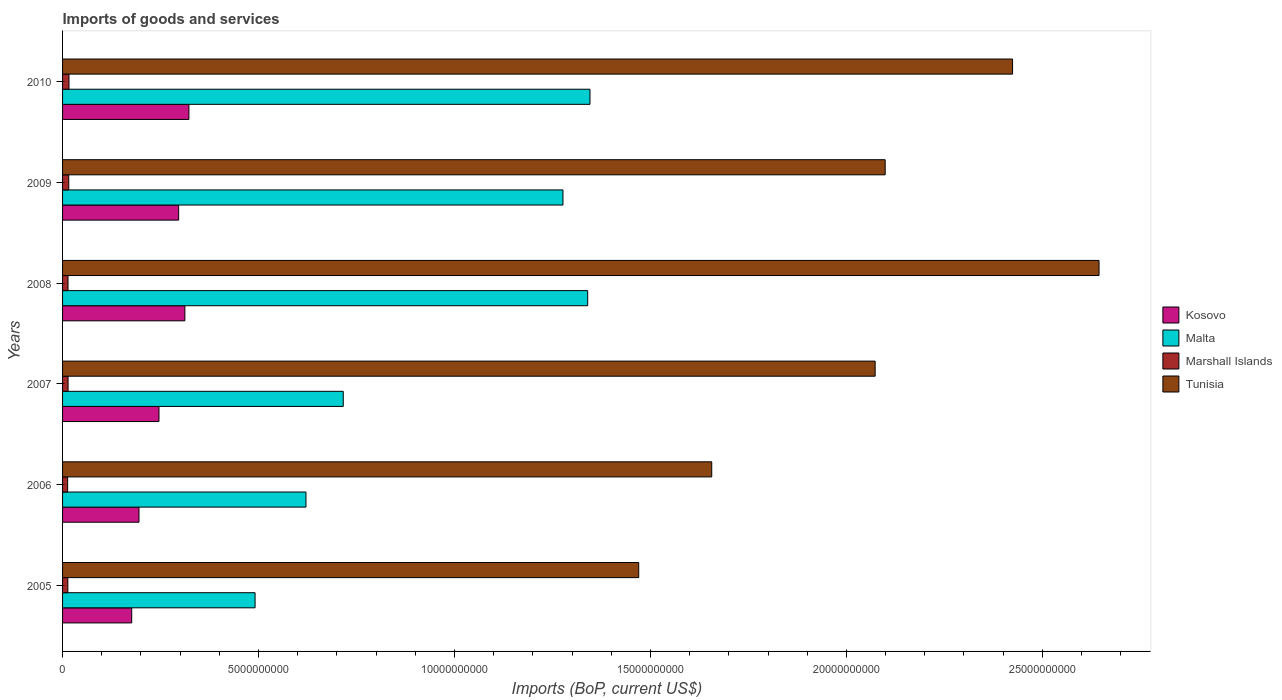How many different coloured bars are there?
Make the answer very short. 4. How many groups of bars are there?
Your answer should be compact. 6. Are the number of bars on each tick of the Y-axis equal?
Provide a succinct answer. Yes. In how many cases, is the number of bars for a given year not equal to the number of legend labels?
Ensure brevity in your answer.  0. What is the amount spent on imports in Kosovo in 2005?
Your answer should be compact. 1.76e+09. Across all years, what is the maximum amount spent on imports in Marshall Islands?
Your response must be concise. 1.64e+08. Across all years, what is the minimum amount spent on imports in Kosovo?
Keep it short and to the point. 1.76e+09. In which year was the amount spent on imports in Tunisia maximum?
Your answer should be very brief. 2008. What is the total amount spent on imports in Kosovo in the graph?
Give a very brief answer. 1.55e+1. What is the difference between the amount spent on imports in Marshall Islands in 2006 and that in 2009?
Offer a terse response. -2.88e+07. What is the difference between the amount spent on imports in Malta in 2006 and the amount spent on imports in Marshall Islands in 2009?
Provide a short and direct response. 6.05e+09. What is the average amount spent on imports in Kosovo per year?
Your answer should be compact. 2.58e+09. In the year 2007, what is the difference between the amount spent on imports in Malta and amount spent on imports in Tunisia?
Offer a terse response. -1.36e+1. What is the ratio of the amount spent on imports in Kosovo in 2007 to that in 2008?
Your answer should be compact. 0.79. Is the difference between the amount spent on imports in Malta in 2006 and 2009 greater than the difference between the amount spent on imports in Tunisia in 2006 and 2009?
Give a very brief answer. No. What is the difference between the highest and the second highest amount spent on imports in Marshall Islands?
Offer a very short reply. 5.73e+06. What is the difference between the highest and the lowest amount spent on imports in Tunisia?
Make the answer very short. 1.17e+1. In how many years, is the amount spent on imports in Tunisia greater than the average amount spent on imports in Tunisia taken over all years?
Offer a terse response. 4. Is the sum of the amount spent on imports in Tunisia in 2005 and 2009 greater than the maximum amount spent on imports in Malta across all years?
Provide a short and direct response. Yes. What does the 3rd bar from the top in 2008 represents?
Make the answer very short. Malta. What does the 3rd bar from the bottom in 2007 represents?
Offer a terse response. Marshall Islands. Is it the case that in every year, the sum of the amount spent on imports in Marshall Islands and amount spent on imports in Kosovo is greater than the amount spent on imports in Malta?
Provide a short and direct response. No. How many bars are there?
Ensure brevity in your answer.  24. How many years are there in the graph?
Offer a terse response. 6. What is the difference between two consecutive major ticks on the X-axis?
Your answer should be very brief. 5.00e+09. Are the values on the major ticks of X-axis written in scientific E-notation?
Your response must be concise. No. Does the graph contain grids?
Ensure brevity in your answer.  No. Where does the legend appear in the graph?
Give a very brief answer. Center right. How are the legend labels stacked?
Provide a short and direct response. Vertical. What is the title of the graph?
Ensure brevity in your answer.  Imports of goods and services. Does "St. Vincent and the Grenadines" appear as one of the legend labels in the graph?
Ensure brevity in your answer.  No. What is the label or title of the X-axis?
Your answer should be very brief. Imports (BoP, current US$). What is the label or title of the Y-axis?
Offer a terse response. Years. What is the Imports (BoP, current US$) of Kosovo in 2005?
Provide a short and direct response. 1.76e+09. What is the Imports (BoP, current US$) of Malta in 2005?
Give a very brief answer. 4.91e+09. What is the Imports (BoP, current US$) in Marshall Islands in 2005?
Your answer should be compact. 1.35e+08. What is the Imports (BoP, current US$) in Tunisia in 2005?
Your response must be concise. 1.47e+1. What is the Imports (BoP, current US$) of Kosovo in 2006?
Offer a terse response. 1.95e+09. What is the Imports (BoP, current US$) of Malta in 2006?
Give a very brief answer. 6.21e+09. What is the Imports (BoP, current US$) of Marshall Islands in 2006?
Your answer should be very brief. 1.29e+08. What is the Imports (BoP, current US$) in Tunisia in 2006?
Your response must be concise. 1.66e+1. What is the Imports (BoP, current US$) of Kosovo in 2007?
Your answer should be very brief. 2.46e+09. What is the Imports (BoP, current US$) of Malta in 2007?
Your answer should be compact. 7.16e+09. What is the Imports (BoP, current US$) in Marshall Islands in 2007?
Offer a very short reply. 1.41e+08. What is the Imports (BoP, current US$) in Tunisia in 2007?
Offer a terse response. 2.07e+1. What is the Imports (BoP, current US$) in Kosovo in 2008?
Keep it short and to the point. 3.12e+09. What is the Imports (BoP, current US$) in Malta in 2008?
Provide a succinct answer. 1.34e+1. What is the Imports (BoP, current US$) in Marshall Islands in 2008?
Ensure brevity in your answer.  1.39e+08. What is the Imports (BoP, current US$) in Tunisia in 2008?
Offer a terse response. 2.64e+1. What is the Imports (BoP, current US$) in Kosovo in 2009?
Your response must be concise. 2.96e+09. What is the Imports (BoP, current US$) in Malta in 2009?
Provide a short and direct response. 1.28e+1. What is the Imports (BoP, current US$) in Marshall Islands in 2009?
Ensure brevity in your answer.  1.58e+08. What is the Imports (BoP, current US$) in Tunisia in 2009?
Ensure brevity in your answer.  2.10e+1. What is the Imports (BoP, current US$) in Kosovo in 2010?
Make the answer very short. 3.22e+09. What is the Imports (BoP, current US$) in Malta in 2010?
Provide a succinct answer. 1.35e+1. What is the Imports (BoP, current US$) of Marshall Islands in 2010?
Your answer should be very brief. 1.64e+08. What is the Imports (BoP, current US$) of Tunisia in 2010?
Ensure brevity in your answer.  2.42e+1. Across all years, what is the maximum Imports (BoP, current US$) in Kosovo?
Provide a short and direct response. 3.22e+09. Across all years, what is the maximum Imports (BoP, current US$) in Malta?
Your answer should be very brief. 1.35e+1. Across all years, what is the maximum Imports (BoP, current US$) of Marshall Islands?
Keep it short and to the point. 1.64e+08. Across all years, what is the maximum Imports (BoP, current US$) of Tunisia?
Provide a short and direct response. 2.64e+1. Across all years, what is the minimum Imports (BoP, current US$) in Kosovo?
Your answer should be compact. 1.76e+09. Across all years, what is the minimum Imports (BoP, current US$) in Malta?
Keep it short and to the point. 4.91e+09. Across all years, what is the minimum Imports (BoP, current US$) of Marshall Islands?
Give a very brief answer. 1.29e+08. Across all years, what is the minimum Imports (BoP, current US$) of Tunisia?
Your response must be concise. 1.47e+1. What is the total Imports (BoP, current US$) of Kosovo in the graph?
Keep it short and to the point. 1.55e+1. What is the total Imports (BoP, current US$) in Malta in the graph?
Give a very brief answer. 5.79e+1. What is the total Imports (BoP, current US$) in Marshall Islands in the graph?
Give a very brief answer. 8.65e+08. What is the total Imports (BoP, current US$) in Tunisia in the graph?
Keep it short and to the point. 1.24e+11. What is the difference between the Imports (BoP, current US$) in Kosovo in 2005 and that in 2006?
Your response must be concise. -1.86e+08. What is the difference between the Imports (BoP, current US$) in Malta in 2005 and that in 2006?
Offer a terse response. -1.30e+09. What is the difference between the Imports (BoP, current US$) of Marshall Islands in 2005 and that in 2006?
Keep it short and to the point. 5.65e+06. What is the difference between the Imports (BoP, current US$) in Tunisia in 2005 and that in 2006?
Keep it short and to the point. -1.86e+09. What is the difference between the Imports (BoP, current US$) of Kosovo in 2005 and that in 2007?
Offer a very short reply. -6.96e+08. What is the difference between the Imports (BoP, current US$) of Malta in 2005 and that in 2007?
Keep it short and to the point. -2.25e+09. What is the difference between the Imports (BoP, current US$) of Marshall Islands in 2005 and that in 2007?
Give a very brief answer. -5.87e+06. What is the difference between the Imports (BoP, current US$) in Tunisia in 2005 and that in 2007?
Give a very brief answer. -6.03e+09. What is the difference between the Imports (BoP, current US$) in Kosovo in 2005 and that in 2008?
Your response must be concise. -1.36e+09. What is the difference between the Imports (BoP, current US$) in Malta in 2005 and that in 2008?
Your answer should be compact. -8.49e+09. What is the difference between the Imports (BoP, current US$) of Marshall Islands in 2005 and that in 2008?
Provide a succinct answer. -4.35e+06. What is the difference between the Imports (BoP, current US$) of Tunisia in 2005 and that in 2008?
Your answer should be compact. -1.17e+1. What is the difference between the Imports (BoP, current US$) in Kosovo in 2005 and that in 2009?
Keep it short and to the point. -1.20e+09. What is the difference between the Imports (BoP, current US$) in Malta in 2005 and that in 2009?
Offer a very short reply. -7.86e+09. What is the difference between the Imports (BoP, current US$) of Marshall Islands in 2005 and that in 2009?
Ensure brevity in your answer.  -2.31e+07. What is the difference between the Imports (BoP, current US$) in Tunisia in 2005 and that in 2009?
Your answer should be compact. -6.29e+09. What is the difference between the Imports (BoP, current US$) in Kosovo in 2005 and that in 2010?
Ensure brevity in your answer.  -1.46e+09. What is the difference between the Imports (BoP, current US$) in Malta in 2005 and that in 2010?
Give a very brief answer. -8.55e+09. What is the difference between the Imports (BoP, current US$) of Marshall Islands in 2005 and that in 2010?
Provide a succinct answer. -2.88e+07. What is the difference between the Imports (BoP, current US$) in Tunisia in 2005 and that in 2010?
Provide a succinct answer. -9.54e+09. What is the difference between the Imports (BoP, current US$) in Kosovo in 2006 and that in 2007?
Provide a short and direct response. -5.10e+08. What is the difference between the Imports (BoP, current US$) in Malta in 2006 and that in 2007?
Offer a terse response. -9.52e+08. What is the difference between the Imports (BoP, current US$) of Marshall Islands in 2006 and that in 2007?
Your answer should be very brief. -1.15e+07. What is the difference between the Imports (BoP, current US$) in Tunisia in 2006 and that in 2007?
Ensure brevity in your answer.  -4.17e+09. What is the difference between the Imports (BoP, current US$) in Kosovo in 2006 and that in 2008?
Your answer should be very brief. -1.17e+09. What is the difference between the Imports (BoP, current US$) in Malta in 2006 and that in 2008?
Your response must be concise. -7.19e+09. What is the difference between the Imports (BoP, current US$) in Marshall Islands in 2006 and that in 2008?
Your answer should be compact. -9.99e+06. What is the difference between the Imports (BoP, current US$) of Tunisia in 2006 and that in 2008?
Provide a short and direct response. -9.88e+09. What is the difference between the Imports (BoP, current US$) of Kosovo in 2006 and that in 2009?
Ensure brevity in your answer.  -1.01e+09. What is the difference between the Imports (BoP, current US$) in Malta in 2006 and that in 2009?
Provide a short and direct response. -6.56e+09. What is the difference between the Imports (BoP, current US$) in Marshall Islands in 2006 and that in 2009?
Give a very brief answer. -2.88e+07. What is the difference between the Imports (BoP, current US$) of Tunisia in 2006 and that in 2009?
Offer a terse response. -4.43e+09. What is the difference between the Imports (BoP, current US$) of Kosovo in 2006 and that in 2010?
Offer a terse response. -1.27e+09. What is the difference between the Imports (BoP, current US$) in Malta in 2006 and that in 2010?
Your answer should be very brief. -7.25e+09. What is the difference between the Imports (BoP, current US$) in Marshall Islands in 2006 and that in 2010?
Provide a succinct answer. -3.45e+07. What is the difference between the Imports (BoP, current US$) of Tunisia in 2006 and that in 2010?
Your answer should be very brief. -7.68e+09. What is the difference between the Imports (BoP, current US$) of Kosovo in 2007 and that in 2008?
Offer a very short reply. -6.61e+08. What is the difference between the Imports (BoP, current US$) of Malta in 2007 and that in 2008?
Provide a succinct answer. -6.24e+09. What is the difference between the Imports (BoP, current US$) in Marshall Islands in 2007 and that in 2008?
Provide a succinct answer. 1.53e+06. What is the difference between the Imports (BoP, current US$) in Tunisia in 2007 and that in 2008?
Your answer should be compact. -5.71e+09. What is the difference between the Imports (BoP, current US$) in Kosovo in 2007 and that in 2009?
Your response must be concise. -5.01e+08. What is the difference between the Imports (BoP, current US$) in Malta in 2007 and that in 2009?
Your answer should be very brief. -5.61e+09. What is the difference between the Imports (BoP, current US$) of Marshall Islands in 2007 and that in 2009?
Your response must be concise. -1.72e+07. What is the difference between the Imports (BoP, current US$) in Tunisia in 2007 and that in 2009?
Give a very brief answer. -2.56e+08. What is the difference between the Imports (BoP, current US$) in Kosovo in 2007 and that in 2010?
Your response must be concise. -7.63e+08. What is the difference between the Imports (BoP, current US$) of Malta in 2007 and that in 2010?
Your response must be concise. -6.30e+09. What is the difference between the Imports (BoP, current US$) in Marshall Islands in 2007 and that in 2010?
Make the answer very short. -2.30e+07. What is the difference between the Imports (BoP, current US$) of Tunisia in 2007 and that in 2010?
Your answer should be very brief. -3.51e+09. What is the difference between the Imports (BoP, current US$) of Kosovo in 2008 and that in 2009?
Your response must be concise. 1.59e+08. What is the difference between the Imports (BoP, current US$) in Malta in 2008 and that in 2009?
Provide a short and direct response. 6.31e+08. What is the difference between the Imports (BoP, current US$) in Marshall Islands in 2008 and that in 2009?
Your answer should be very brief. -1.88e+07. What is the difference between the Imports (BoP, current US$) of Tunisia in 2008 and that in 2009?
Your answer should be compact. 5.46e+09. What is the difference between the Imports (BoP, current US$) of Kosovo in 2008 and that in 2010?
Your answer should be compact. -1.03e+08. What is the difference between the Imports (BoP, current US$) of Malta in 2008 and that in 2010?
Give a very brief answer. -5.88e+07. What is the difference between the Imports (BoP, current US$) of Marshall Islands in 2008 and that in 2010?
Provide a succinct answer. -2.45e+07. What is the difference between the Imports (BoP, current US$) in Tunisia in 2008 and that in 2010?
Your answer should be very brief. 2.21e+09. What is the difference between the Imports (BoP, current US$) of Kosovo in 2009 and that in 2010?
Ensure brevity in your answer.  -2.62e+08. What is the difference between the Imports (BoP, current US$) of Malta in 2009 and that in 2010?
Your answer should be very brief. -6.89e+08. What is the difference between the Imports (BoP, current US$) in Marshall Islands in 2009 and that in 2010?
Ensure brevity in your answer.  -5.73e+06. What is the difference between the Imports (BoP, current US$) of Tunisia in 2009 and that in 2010?
Give a very brief answer. -3.25e+09. What is the difference between the Imports (BoP, current US$) of Kosovo in 2005 and the Imports (BoP, current US$) of Malta in 2006?
Make the answer very short. -4.45e+09. What is the difference between the Imports (BoP, current US$) in Kosovo in 2005 and the Imports (BoP, current US$) in Marshall Islands in 2006?
Offer a terse response. 1.64e+09. What is the difference between the Imports (BoP, current US$) of Kosovo in 2005 and the Imports (BoP, current US$) of Tunisia in 2006?
Ensure brevity in your answer.  -1.48e+1. What is the difference between the Imports (BoP, current US$) in Malta in 2005 and the Imports (BoP, current US$) in Marshall Islands in 2006?
Offer a terse response. 4.78e+09. What is the difference between the Imports (BoP, current US$) in Malta in 2005 and the Imports (BoP, current US$) in Tunisia in 2006?
Your answer should be compact. -1.17e+1. What is the difference between the Imports (BoP, current US$) in Marshall Islands in 2005 and the Imports (BoP, current US$) in Tunisia in 2006?
Your response must be concise. -1.64e+1. What is the difference between the Imports (BoP, current US$) of Kosovo in 2005 and the Imports (BoP, current US$) of Malta in 2007?
Give a very brief answer. -5.40e+09. What is the difference between the Imports (BoP, current US$) in Kosovo in 2005 and the Imports (BoP, current US$) in Marshall Islands in 2007?
Provide a succinct answer. 1.62e+09. What is the difference between the Imports (BoP, current US$) of Kosovo in 2005 and the Imports (BoP, current US$) of Tunisia in 2007?
Your answer should be compact. -1.90e+1. What is the difference between the Imports (BoP, current US$) in Malta in 2005 and the Imports (BoP, current US$) in Marshall Islands in 2007?
Ensure brevity in your answer.  4.77e+09. What is the difference between the Imports (BoP, current US$) in Malta in 2005 and the Imports (BoP, current US$) in Tunisia in 2007?
Your answer should be compact. -1.58e+1. What is the difference between the Imports (BoP, current US$) of Marshall Islands in 2005 and the Imports (BoP, current US$) of Tunisia in 2007?
Offer a terse response. -2.06e+1. What is the difference between the Imports (BoP, current US$) in Kosovo in 2005 and the Imports (BoP, current US$) in Malta in 2008?
Offer a terse response. -1.16e+1. What is the difference between the Imports (BoP, current US$) in Kosovo in 2005 and the Imports (BoP, current US$) in Marshall Islands in 2008?
Keep it short and to the point. 1.63e+09. What is the difference between the Imports (BoP, current US$) in Kosovo in 2005 and the Imports (BoP, current US$) in Tunisia in 2008?
Provide a succinct answer. -2.47e+1. What is the difference between the Imports (BoP, current US$) in Malta in 2005 and the Imports (BoP, current US$) in Marshall Islands in 2008?
Keep it short and to the point. 4.77e+09. What is the difference between the Imports (BoP, current US$) of Malta in 2005 and the Imports (BoP, current US$) of Tunisia in 2008?
Your answer should be compact. -2.15e+1. What is the difference between the Imports (BoP, current US$) in Marshall Islands in 2005 and the Imports (BoP, current US$) in Tunisia in 2008?
Ensure brevity in your answer.  -2.63e+1. What is the difference between the Imports (BoP, current US$) in Kosovo in 2005 and the Imports (BoP, current US$) in Malta in 2009?
Offer a very short reply. -1.10e+1. What is the difference between the Imports (BoP, current US$) of Kosovo in 2005 and the Imports (BoP, current US$) of Marshall Islands in 2009?
Make the answer very short. 1.61e+09. What is the difference between the Imports (BoP, current US$) in Kosovo in 2005 and the Imports (BoP, current US$) in Tunisia in 2009?
Make the answer very short. -1.92e+1. What is the difference between the Imports (BoP, current US$) of Malta in 2005 and the Imports (BoP, current US$) of Marshall Islands in 2009?
Your answer should be compact. 4.75e+09. What is the difference between the Imports (BoP, current US$) of Malta in 2005 and the Imports (BoP, current US$) of Tunisia in 2009?
Give a very brief answer. -1.61e+1. What is the difference between the Imports (BoP, current US$) in Marshall Islands in 2005 and the Imports (BoP, current US$) in Tunisia in 2009?
Ensure brevity in your answer.  -2.09e+1. What is the difference between the Imports (BoP, current US$) in Kosovo in 2005 and the Imports (BoP, current US$) in Malta in 2010?
Ensure brevity in your answer.  -1.17e+1. What is the difference between the Imports (BoP, current US$) of Kosovo in 2005 and the Imports (BoP, current US$) of Marshall Islands in 2010?
Make the answer very short. 1.60e+09. What is the difference between the Imports (BoP, current US$) in Kosovo in 2005 and the Imports (BoP, current US$) in Tunisia in 2010?
Make the answer very short. -2.25e+1. What is the difference between the Imports (BoP, current US$) of Malta in 2005 and the Imports (BoP, current US$) of Marshall Islands in 2010?
Provide a succinct answer. 4.75e+09. What is the difference between the Imports (BoP, current US$) of Malta in 2005 and the Imports (BoP, current US$) of Tunisia in 2010?
Your response must be concise. -1.93e+1. What is the difference between the Imports (BoP, current US$) in Marshall Islands in 2005 and the Imports (BoP, current US$) in Tunisia in 2010?
Provide a short and direct response. -2.41e+1. What is the difference between the Imports (BoP, current US$) of Kosovo in 2006 and the Imports (BoP, current US$) of Malta in 2007?
Keep it short and to the point. -5.21e+09. What is the difference between the Imports (BoP, current US$) in Kosovo in 2006 and the Imports (BoP, current US$) in Marshall Islands in 2007?
Your response must be concise. 1.81e+09. What is the difference between the Imports (BoP, current US$) of Kosovo in 2006 and the Imports (BoP, current US$) of Tunisia in 2007?
Provide a short and direct response. -1.88e+1. What is the difference between the Imports (BoP, current US$) in Malta in 2006 and the Imports (BoP, current US$) in Marshall Islands in 2007?
Your answer should be compact. 6.07e+09. What is the difference between the Imports (BoP, current US$) in Malta in 2006 and the Imports (BoP, current US$) in Tunisia in 2007?
Offer a terse response. -1.45e+1. What is the difference between the Imports (BoP, current US$) in Marshall Islands in 2006 and the Imports (BoP, current US$) in Tunisia in 2007?
Offer a terse response. -2.06e+1. What is the difference between the Imports (BoP, current US$) of Kosovo in 2006 and the Imports (BoP, current US$) of Malta in 2008?
Give a very brief answer. -1.14e+1. What is the difference between the Imports (BoP, current US$) of Kosovo in 2006 and the Imports (BoP, current US$) of Marshall Islands in 2008?
Provide a succinct answer. 1.81e+09. What is the difference between the Imports (BoP, current US$) of Kosovo in 2006 and the Imports (BoP, current US$) of Tunisia in 2008?
Give a very brief answer. -2.45e+1. What is the difference between the Imports (BoP, current US$) in Malta in 2006 and the Imports (BoP, current US$) in Marshall Islands in 2008?
Provide a succinct answer. 6.07e+09. What is the difference between the Imports (BoP, current US$) of Malta in 2006 and the Imports (BoP, current US$) of Tunisia in 2008?
Give a very brief answer. -2.02e+1. What is the difference between the Imports (BoP, current US$) of Marshall Islands in 2006 and the Imports (BoP, current US$) of Tunisia in 2008?
Your answer should be very brief. -2.63e+1. What is the difference between the Imports (BoP, current US$) of Kosovo in 2006 and the Imports (BoP, current US$) of Malta in 2009?
Make the answer very short. -1.08e+1. What is the difference between the Imports (BoP, current US$) in Kosovo in 2006 and the Imports (BoP, current US$) in Marshall Islands in 2009?
Offer a very short reply. 1.79e+09. What is the difference between the Imports (BoP, current US$) in Kosovo in 2006 and the Imports (BoP, current US$) in Tunisia in 2009?
Provide a short and direct response. -1.90e+1. What is the difference between the Imports (BoP, current US$) of Malta in 2006 and the Imports (BoP, current US$) of Marshall Islands in 2009?
Keep it short and to the point. 6.05e+09. What is the difference between the Imports (BoP, current US$) of Malta in 2006 and the Imports (BoP, current US$) of Tunisia in 2009?
Make the answer very short. -1.48e+1. What is the difference between the Imports (BoP, current US$) of Marshall Islands in 2006 and the Imports (BoP, current US$) of Tunisia in 2009?
Ensure brevity in your answer.  -2.09e+1. What is the difference between the Imports (BoP, current US$) in Kosovo in 2006 and the Imports (BoP, current US$) in Malta in 2010?
Provide a short and direct response. -1.15e+1. What is the difference between the Imports (BoP, current US$) in Kosovo in 2006 and the Imports (BoP, current US$) in Marshall Islands in 2010?
Offer a terse response. 1.79e+09. What is the difference between the Imports (BoP, current US$) of Kosovo in 2006 and the Imports (BoP, current US$) of Tunisia in 2010?
Your answer should be compact. -2.23e+1. What is the difference between the Imports (BoP, current US$) in Malta in 2006 and the Imports (BoP, current US$) in Marshall Islands in 2010?
Make the answer very short. 6.05e+09. What is the difference between the Imports (BoP, current US$) in Malta in 2006 and the Imports (BoP, current US$) in Tunisia in 2010?
Give a very brief answer. -1.80e+1. What is the difference between the Imports (BoP, current US$) in Marshall Islands in 2006 and the Imports (BoP, current US$) in Tunisia in 2010?
Offer a terse response. -2.41e+1. What is the difference between the Imports (BoP, current US$) in Kosovo in 2007 and the Imports (BoP, current US$) in Malta in 2008?
Give a very brief answer. -1.09e+1. What is the difference between the Imports (BoP, current US$) in Kosovo in 2007 and the Imports (BoP, current US$) in Marshall Islands in 2008?
Give a very brief answer. 2.32e+09. What is the difference between the Imports (BoP, current US$) in Kosovo in 2007 and the Imports (BoP, current US$) in Tunisia in 2008?
Your answer should be compact. -2.40e+1. What is the difference between the Imports (BoP, current US$) in Malta in 2007 and the Imports (BoP, current US$) in Marshall Islands in 2008?
Your response must be concise. 7.02e+09. What is the difference between the Imports (BoP, current US$) of Malta in 2007 and the Imports (BoP, current US$) of Tunisia in 2008?
Offer a terse response. -1.93e+1. What is the difference between the Imports (BoP, current US$) of Marshall Islands in 2007 and the Imports (BoP, current US$) of Tunisia in 2008?
Offer a very short reply. -2.63e+1. What is the difference between the Imports (BoP, current US$) in Kosovo in 2007 and the Imports (BoP, current US$) in Malta in 2009?
Offer a terse response. -1.03e+1. What is the difference between the Imports (BoP, current US$) in Kosovo in 2007 and the Imports (BoP, current US$) in Marshall Islands in 2009?
Offer a terse response. 2.30e+09. What is the difference between the Imports (BoP, current US$) in Kosovo in 2007 and the Imports (BoP, current US$) in Tunisia in 2009?
Offer a very short reply. -1.85e+1. What is the difference between the Imports (BoP, current US$) of Malta in 2007 and the Imports (BoP, current US$) of Marshall Islands in 2009?
Offer a very short reply. 7.00e+09. What is the difference between the Imports (BoP, current US$) in Malta in 2007 and the Imports (BoP, current US$) in Tunisia in 2009?
Provide a short and direct response. -1.38e+1. What is the difference between the Imports (BoP, current US$) in Marshall Islands in 2007 and the Imports (BoP, current US$) in Tunisia in 2009?
Provide a short and direct response. -2.08e+1. What is the difference between the Imports (BoP, current US$) of Kosovo in 2007 and the Imports (BoP, current US$) of Malta in 2010?
Provide a succinct answer. -1.10e+1. What is the difference between the Imports (BoP, current US$) in Kosovo in 2007 and the Imports (BoP, current US$) in Marshall Islands in 2010?
Keep it short and to the point. 2.30e+09. What is the difference between the Imports (BoP, current US$) in Kosovo in 2007 and the Imports (BoP, current US$) in Tunisia in 2010?
Provide a succinct answer. -2.18e+1. What is the difference between the Imports (BoP, current US$) in Malta in 2007 and the Imports (BoP, current US$) in Marshall Islands in 2010?
Provide a short and direct response. 7.00e+09. What is the difference between the Imports (BoP, current US$) of Malta in 2007 and the Imports (BoP, current US$) of Tunisia in 2010?
Your response must be concise. -1.71e+1. What is the difference between the Imports (BoP, current US$) of Marshall Islands in 2007 and the Imports (BoP, current US$) of Tunisia in 2010?
Offer a very short reply. -2.41e+1. What is the difference between the Imports (BoP, current US$) in Kosovo in 2008 and the Imports (BoP, current US$) in Malta in 2009?
Your answer should be very brief. -9.65e+09. What is the difference between the Imports (BoP, current US$) of Kosovo in 2008 and the Imports (BoP, current US$) of Marshall Islands in 2009?
Your answer should be very brief. 2.96e+09. What is the difference between the Imports (BoP, current US$) in Kosovo in 2008 and the Imports (BoP, current US$) in Tunisia in 2009?
Ensure brevity in your answer.  -1.79e+1. What is the difference between the Imports (BoP, current US$) in Malta in 2008 and the Imports (BoP, current US$) in Marshall Islands in 2009?
Offer a terse response. 1.32e+1. What is the difference between the Imports (BoP, current US$) in Malta in 2008 and the Imports (BoP, current US$) in Tunisia in 2009?
Make the answer very short. -7.59e+09. What is the difference between the Imports (BoP, current US$) of Marshall Islands in 2008 and the Imports (BoP, current US$) of Tunisia in 2009?
Make the answer very short. -2.09e+1. What is the difference between the Imports (BoP, current US$) in Kosovo in 2008 and the Imports (BoP, current US$) in Malta in 2010?
Give a very brief answer. -1.03e+1. What is the difference between the Imports (BoP, current US$) in Kosovo in 2008 and the Imports (BoP, current US$) in Marshall Islands in 2010?
Your response must be concise. 2.96e+09. What is the difference between the Imports (BoP, current US$) of Kosovo in 2008 and the Imports (BoP, current US$) of Tunisia in 2010?
Your answer should be very brief. -2.11e+1. What is the difference between the Imports (BoP, current US$) in Malta in 2008 and the Imports (BoP, current US$) in Marshall Islands in 2010?
Your response must be concise. 1.32e+1. What is the difference between the Imports (BoP, current US$) of Malta in 2008 and the Imports (BoP, current US$) of Tunisia in 2010?
Provide a succinct answer. -1.08e+1. What is the difference between the Imports (BoP, current US$) in Marshall Islands in 2008 and the Imports (BoP, current US$) in Tunisia in 2010?
Keep it short and to the point. -2.41e+1. What is the difference between the Imports (BoP, current US$) of Kosovo in 2009 and the Imports (BoP, current US$) of Malta in 2010?
Offer a terse response. -1.05e+1. What is the difference between the Imports (BoP, current US$) of Kosovo in 2009 and the Imports (BoP, current US$) of Marshall Islands in 2010?
Keep it short and to the point. 2.80e+09. What is the difference between the Imports (BoP, current US$) of Kosovo in 2009 and the Imports (BoP, current US$) of Tunisia in 2010?
Offer a very short reply. -2.13e+1. What is the difference between the Imports (BoP, current US$) of Malta in 2009 and the Imports (BoP, current US$) of Marshall Islands in 2010?
Make the answer very short. 1.26e+1. What is the difference between the Imports (BoP, current US$) of Malta in 2009 and the Imports (BoP, current US$) of Tunisia in 2010?
Your answer should be compact. -1.15e+1. What is the difference between the Imports (BoP, current US$) in Marshall Islands in 2009 and the Imports (BoP, current US$) in Tunisia in 2010?
Provide a succinct answer. -2.41e+1. What is the average Imports (BoP, current US$) in Kosovo per year?
Offer a terse response. 2.58e+09. What is the average Imports (BoP, current US$) in Malta per year?
Ensure brevity in your answer.  9.65e+09. What is the average Imports (BoP, current US$) in Marshall Islands per year?
Offer a terse response. 1.44e+08. What is the average Imports (BoP, current US$) of Tunisia per year?
Provide a succinct answer. 2.06e+1. In the year 2005, what is the difference between the Imports (BoP, current US$) of Kosovo and Imports (BoP, current US$) of Malta?
Keep it short and to the point. -3.15e+09. In the year 2005, what is the difference between the Imports (BoP, current US$) of Kosovo and Imports (BoP, current US$) of Marshall Islands?
Provide a short and direct response. 1.63e+09. In the year 2005, what is the difference between the Imports (BoP, current US$) of Kosovo and Imports (BoP, current US$) of Tunisia?
Keep it short and to the point. -1.29e+1. In the year 2005, what is the difference between the Imports (BoP, current US$) of Malta and Imports (BoP, current US$) of Marshall Islands?
Offer a very short reply. 4.78e+09. In the year 2005, what is the difference between the Imports (BoP, current US$) of Malta and Imports (BoP, current US$) of Tunisia?
Make the answer very short. -9.79e+09. In the year 2005, what is the difference between the Imports (BoP, current US$) of Marshall Islands and Imports (BoP, current US$) of Tunisia?
Offer a terse response. -1.46e+1. In the year 2006, what is the difference between the Imports (BoP, current US$) of Kosovo and Imports (BoP, current US$) of Malta?
Your answer should be compact. -4.26e+09. In the year 2006, what is the difference between the Imports (BoP, current US$) of Kosovo and Imports (BoP, current US$) of Marshall Islands?
Your answer should be compact. 1.82e+09. In the year 2006, what is the difference between the Imports (BoP, current US$) in Kosovo and Imports (BoP, current US$) in Tunisia?
Your answer should be very brief. -1.46e+1. In the year 2006, what is the difference between the Imports (BoP, current US$) of Malta and Imports (BoP, current US$) of Marshall Islands?
Give a very brief answer. 6.08e+09. In the year 2006, what is the difference between the Imports (BoP, current US$) in Malta and Imports (BoP, current US$) in Tunisia?
Offer a terse response. -1.04e+1. In the year 2006, what is the difference between the Imports (BoP, current US$) in Marshall Islands and Imports (BoP, current US$) in Tunisia?
Provide a short and direct response. -1.64e+1. In the year 2007, what is the difference between the Imports (BoP, current US$) of Kosovo and Imports (BoP, current US$) of Malta?
Your response must be concise. -4.70e+09. In the year 2007, what is the difference between the Imports (BoP, current US$) in Kosovo and Imports (BoP, current US$) in Marshall Islands?
Keep it short and to the point. 2.32e+09. In the year 2007, what is the difference between the Imports (BoP, current US$) of Kosovo and Imports (BoP, current US$) of Tunisia?
Your response must be concise. -1.83e+1. In the year 2007, what is the difference between the Imports (BoP, current US$) in Malta and Imports (BoP, current US$) in Marshall Islands?
Offer a very short reply. 7.02e+09. In the year 2007, what is the difference between the Imports (BoP, current US$) of Malta and Imports (BoP, current US$) of Tunisia?
Offer a very short reply. -1.36e+1. In the year 2007, what is the difference between the Imports (BoP, current US$) of Marshall Islands and Imports (BoP, current US$) of Tunisia?
Your answer should be compact. -2.06e+1. In the year 2008, what is the difference between the Imports (BoP, current US$) in Kosovo and Imports (BoP, current US$) in Malta?
Offer a very short reply. -1.03e+1. In the year 2008, what is the difference between the Imports (BoP, current US$) in Kosovo and Imports (BoP, current US$) in Marshall Islands?
Your answer should be compact. 2.98e+09. In the year 2008, what is the difference between the Imports (BoP, current US$) of Kosovo and Imports (BoP, current US$) of Tunisia?
Your response must be concise. -2.33e+1. In the year 2008, what is the difference between the Imports (BoP, current US$) in Malta and Imports (BoP, current US$) in Marshall Islands?
Your response must be concise. 1.33e+1. In the year 2008, what is the difference between the Imports (BoP, current US$) of Malta and Imports (BoP, current US$) of Tunisia?
Ensure brevity in your answer.  -1.30e+1. In the year 2008, what is the difference between the Imports (BoP, current US$) of Marshall Islands and Imports (BoP, current US$) of Tunisia?
Offer a very short reply. -2.63e+1. In the year 2009, what is the difference between the Imports (BoP, current US$) of Kosovo and Imports (BoP, current US$) of Malta?
Offer a terse response. -9.81e+09. In the year 2009, what is the difference between the Imports (BoP, current US$) in Kosovo and Imports (BoP, current US$) in Marshall Islands?
Give a very brief answer. 2.80e+09. In the year 2009, what is the difference between the Imports (BoP, current US$) in Kosovo and Imports (BoP, current US$) in Tunisia?
Keep it short and to the point. -1.80e+1. In the year 2009, what is the difference between the Imports (BoP, current US$) of Malta and Imports (BoP, current US$) of Marshall Islands?
Your response must be concise. 1.26e+1. In the year 2009, what is the difference between the Imports (BoP, current US$) of Malta and Imports (BoP, current US$) of Tunisia?
Keep it short and to the point. -8.22e+09. In the year 2009, what is the difference between the Imports (BoP, current US$) of Marshall Islands and Imports (BoP, current US$) of Tunisia?
Keep it short and to the point. -2.08e+1. In the year 2010, what is the difference between the Imports (BoP, current US$) in Kosovo and Imports (BoP, current US$) in Malta?
Ensure brevity in your answer.  -1.02e+1. In the year 2010, what is the difference between the Imports (BoP, current US$) in Kosovo and Imports (BoP, current US$) in Marshall Islands?
Offer a terse response. 3.06e+09. In the year 2010, what is the difference between the Imports (BoP, current US$) in Kosovo and Imports (BoP, current US$) in Tunisia?
Your answer should be compact. -2.10e+1. In the year 2010, what is the difference between the Imports (BoP, current US$) in Malta and Imports (BoP, current US$) in Marshall Islands?
Offer a very short reply. 1.33e+1. In the year 2010, what is the difference between the Imports (BoP, current US$) in Malta and Imports (BoP, current US$) in Tunisia?
Your answer should be very brief. -1.08e+1. In the year 2010, what is the difference between the Imports (BoP, current US$) in Marshall Islands and Imports (BoP, current US$) in Tunisia?
Provide a succinct answer. -2.41e+1. What is the ratio of the Imports (BoP, current US$) of Kosovo in 2005 to that in 2006?
Your answer should be very brief. 0.9. What is the ratio of the Imports (BoP, current US$) of Malta in 2005 to that in 2006?
Keep it short and to the point. 0.79. What is the ratio of the Imports (BoP, current US$) of Marshall Islands in 2005 to that in 2006?
Your answer should be compact. 1.04. What is the ratio of the Imports (BoP, current US$) in Tunisia in 2005 to that in 2006?
Provide a succinct answer. 0.89. What is the ratio of the Imports (BoP, current US$) in Kosovo in 2005 to that in 2007?
Your answer should be compact. 0.72. What is the ratio of the Imports (BoP, current US$) of Malta in 2005 to that in 2007?
Offer a terse response. 0.69. What is the ratio of the Imports (BoP, current US$) of Marshall Islands in 2005 to that in 2007?
Keep it short and to the point. 0.96. What is the ratio of the Imports (BoP, current US$) of Tunisia in 2005 to that in 2007?
Offer a very short reply. 0.71. What is the ratio of the Imports (BoP, current US$) of Kosovo in 2005 to that in 2008?
Provide a short and direct response. 0.57. What is the ratio of the Imports (BoP, current US$) in Malta in 2005 to that in 2008?
Offer a very short reply. 0.37. What is the ratio of the Imports (BoP, current US$) of Marshall Islands in 2005 to that in 2008?
Give a very brief answer. 0.97. What is the ratio of the Imports (BoP, current US$) of Tunisia in 2005 to that in 2008?
Your answer should be very brief. 0.56. What is the ratio of the Imports (BoP, current US$) of Kosovo in 2005 to that in 2009?
Keep it short and to the point. 0.6. What is the ratio of the Imports (BoP, current US$) in Malta in 2005 to that in 2009?
Provide a succinct answer. 0.38. What is the ratio of the Imports (BoP, current US$) of Marshall Islands in 2005 to that in 2009?
Keep it short and to the point. 0.85. What is the ratio of the Imports (BoP, current US$) of Tunisia in 2005 to that in 2009?
Keep it short and to the point. 0.7. What is the ratio of the Imports (BoP, current US$) of Kosovo in 2005 to that in 2010?
Provide a succinct answer. 0.55. What is the ratio of the Imports (BoP, current US$) of Malta in 2005 to that in 2010?
Ensure brevity in your answer.  0.36. What is the ratio of the Imports (BoP, current US$) of Marshall Islands in 2005 to that in 2010?
Make the answer very short. 0.82. What is the ratio of the Imports (BoP, current US$) in Tunisia in 2005 to that in 2010?
Ensure brevity in your answer.  0.61. What is the ratio of the Imports (BoP, current US$) of Kosovo in 2006 to that in 2007?
Give a very brief answer. 0.79. What is the ratio of the Imports (BoP, current US$) in Malta in 2006 to that in 2007?
Offer a terse response. 0.87. What is the ratio of the Imports (BoP, current US$) of Marshall Islands in 2006 to that in 2007?
Make the answer very short. 0.92. What is the ratio of the Imports (BoP, current US$) of Tunisia in 2006 to that in 2007?
Provide a short and direct response. 0.8. What is the ratio of the Imports (BoP, current US$) in Kosovo in 2006 to that in 2008?
Give a very brief answer. 0.62. What is the ratio of the Imports (BoP, current US$) of Malta in 2006 to that in 2008?
Give a very brief answer. 0.46. What is the ratio of the Imports (BoP, current US$) of Marshall Islands in 2006 to that in 2008?
Keep it short and to the point. 0.93. What is the ratio of the Imports (BoP, current US$) in Tunisia in 2006 to that in 2008?
Your answer should be compact. 0.63. What is the ratio of the Imports (BoP, current US$) in Kosovo in 2006 to that in 2009?
Your answer should be compact. 0.66. What is the ratio of the Imports (BoP, current US$) of Malta in 2006 to that in 2009?
Keep it short and to the point. 0.49. What is the ratio of the Imports (BoP, current US$) of Marshall Islands in 2006 to that in 2009?
Offer a terse response. 0.82. What is the ratio of the Imports (BoP, current US$) in Tunisia in 2006 to that in 2009?
Offer a very short reply. 0.79. What is the ratio of the Imports (BoP, current US$) of Kosovo in 2006 to that in 2010?
Ensure brevity in your answer.  0.6. What is the ratio of the Imports (BoP, current US$) of Malta in 2006 to that in 2010?
Make the answer very short. 0.46. What is the ratio of the Imports (BoP, current US$) in Marshall Islands in 2006 to that in 2010?
Keep it short and to the point. 0.79. What is the ratio of the Imports (BoP, current US$) of Tunisia in 2006 to that in 2010?
Provide a short and direct response. 0.68. What is the ratio of the Imports (BoP, current US$) in Kosovo in 2007 to that in 2008?
Your answer should be compact. 0.79. What is the ratio of the Imports (BoP, current US$) of Malta in 2007 to that in 2008?
Offer a terse response. 0.53. What is the ratio of the Imports (BoP, current US$) of Tunisia in 2007 to that in 2008?
Your response must be concise. 0.78. What is the ratio of the Imports (BoP, current US$) in Kosovo in 2007 to that in 2009?
Your response must be concise. 0.83. What is the ratio of the Imports (BoP, current US$) in Malta in 2007 to that in 2009?
Keep it short and to the point. 0.56. What is the ratio of the Imports (BoP, current US$) of Marshall Islands in 2007 to that in 2009?
Make the answer very short. 0.89. What is the ratio of the Imports (BoP, current US$) of Tunisia in 2007 to that in 2009?
Give a very brief answer. 0.99. What is the ratio of the Imports (BoP, current US$) in Kosovo in 2007 to that in 2010?
Offer a very short reply. 0.76. What is the ratio of the Imports (BoP, current US$) in Malta in 2007 to that in 2010?
Offer a very short reply. 0.53. What is the ratio of the Imports (BoP, current US$) of Marshall Islands in 2007 to that in 2010?
Your answer should be very brief. 0.86. What is the ratio of the Imports (BoP, current US$) in Tunisia in 2007 to that in 2010?
Ensure brevity in your answer.  0.86. What is the ratio of the Imports (BoP, current US$) in Kosovo in 2008 to that in 2009?
Ensure brevity in your answer.  1.05. What is the ratio of the Imports (BoP, current US$) in Malta in 2008 to that in 2009?
Your answer should be very brief. 1.05. What is the ratio of the Imports (BoP, current US$) in Marshall Islands in 2008 to that in 2009?
Your response must be concise. 0.88. What is the ratio of the Imports (BoP, current US$) of Tunisia in 2008 to that in 2009?
Make the answer very short. 1.26. What is the ratio of the Imports (BoP, current US$) of Kosovo in 2008 to that in 2010?
Ensure brevity in your answer.  0.97. What is the ratio of the Imports (BoP, current US$) of Marshall Islands in 2008 to that in 2010?
Provide a short and direct response. 0.85. What is the ratio of the Imports (BoP, current US$) of Tunisia in 2008 to that in 2010?
Provide a short and direct response. 1.09. What is the ratio of the Imports (BoP, current US$) of Kosovo in 2009 to that in 2010?
Offer a very short reply. 0.92. What is the ratio of the Imports (BoP, current US$) in Malta in 2009 to that in 2010?
Keep it short and to the point. 0.95. What is the ratio of the Imports (BoP, current US$) in Tunisia in 2009 to that in 2010?
Make the answer very short. 0.87. What is the difference between the highest and the second highest Imports (BoP, current US$) of Kosovo?
Your answer should be compact. 1.03e+08. What is the difference between the highest and the second highest Imports (BoP, current US$) in Malta?
Make the answer very short. 5.88e+07. What is the difference between the highest and the second highest Imports (BoP, current US$) in Marshall Islands?
Make the answer very short. 5.73e+06. What is the difference between the highest and the second highest Imports (BoP, current US$) in Tunisia?
Your answer should be compact. 2.21e+09. What is the difference between the highest and the lowest Imports (BoP, current US$) in Kosovo?
Your response must be concise. 1.46e+09. What is the difference between the highest and the lowest Imports (BoP, current US$) in Malta?
Keep it short and to the point. 8.55e+09. What is the difference between the highest and the lowest Imports (BoP, current US$) in Marshall Islands?
Ensure brevity in your answer.  3.45e+07. What is the difference between the highest and the lowest Imports (BoP, current US$) of Tunisia?
Provide a short and direct response. 1.17e+1. 